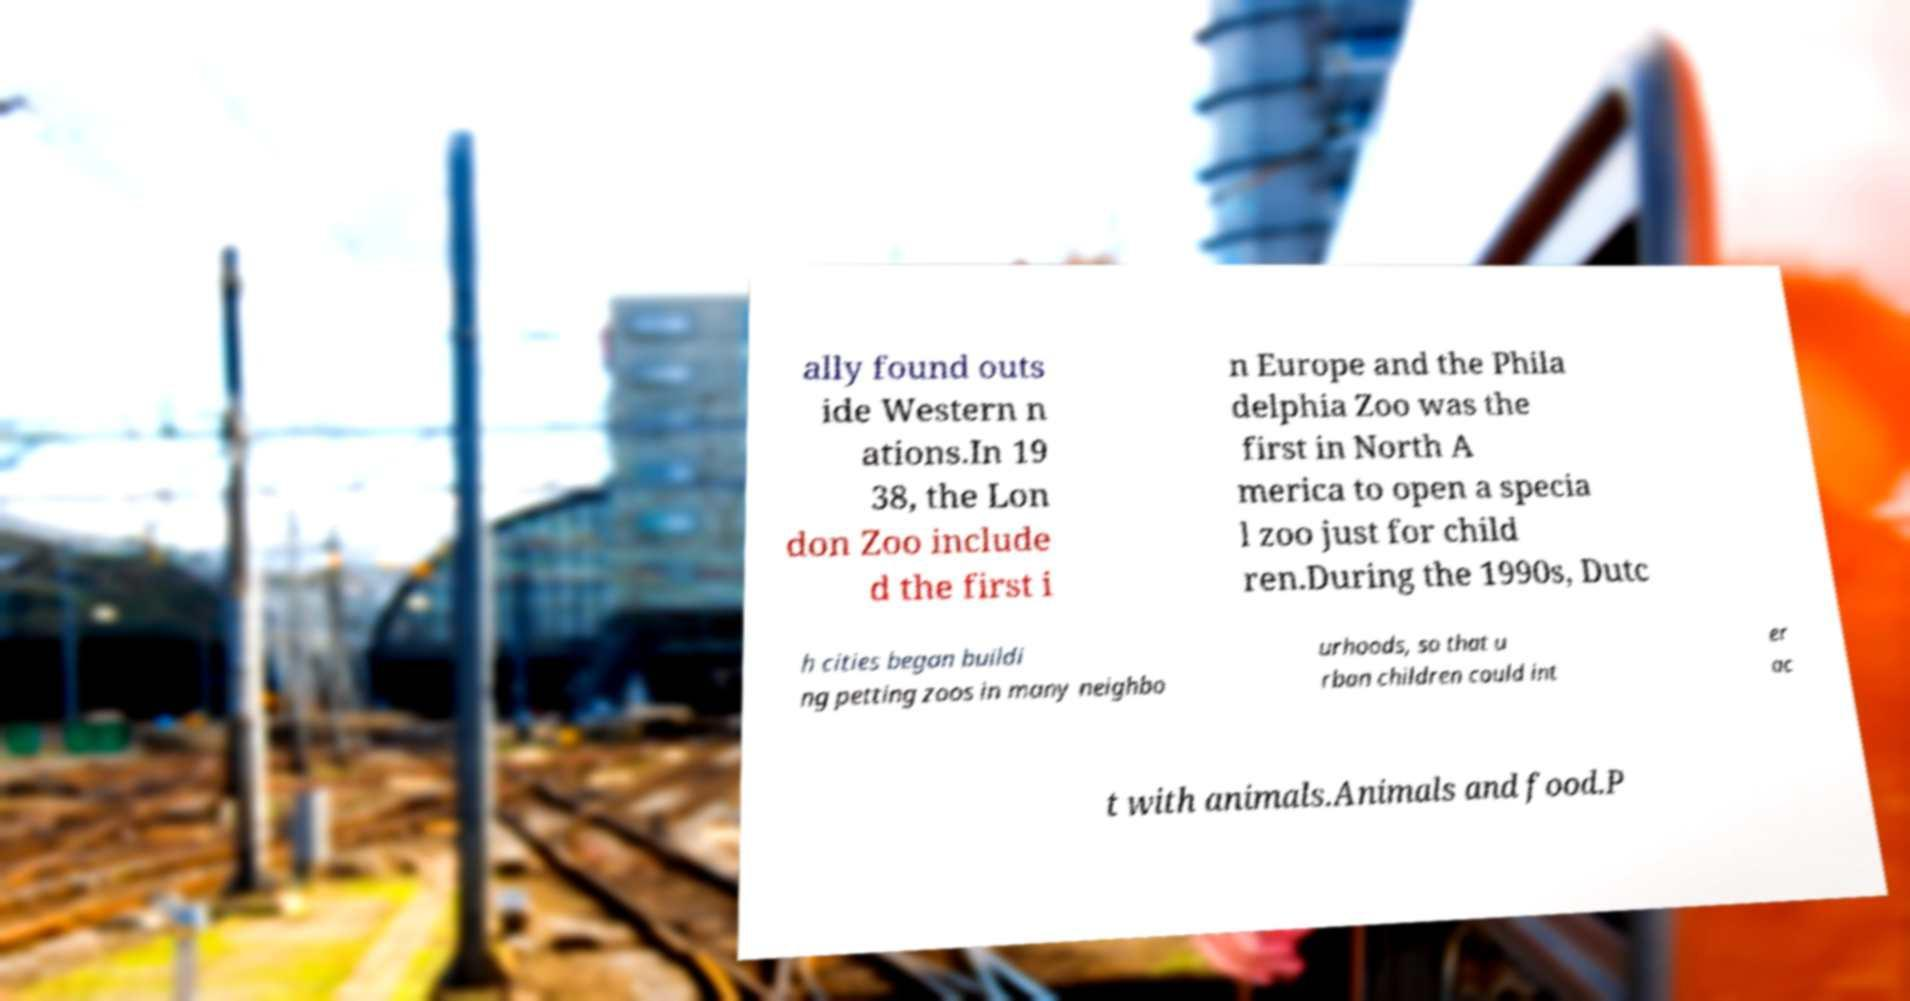What messages or text are displayed in this image? I need them in a readable, typed format. ally found outs ide Western n ations.In 19 38, the Lon don Zoo include d the first i n Europe and the Phila delphia Zoo was the first in North A merica to open a specia l zoo just for child ren.During the 1990s, Dutc h cities began buildi ng petting zoos in many neighbo urhoods, so that u rban children could int er ac t with animals.Animals and food.P 